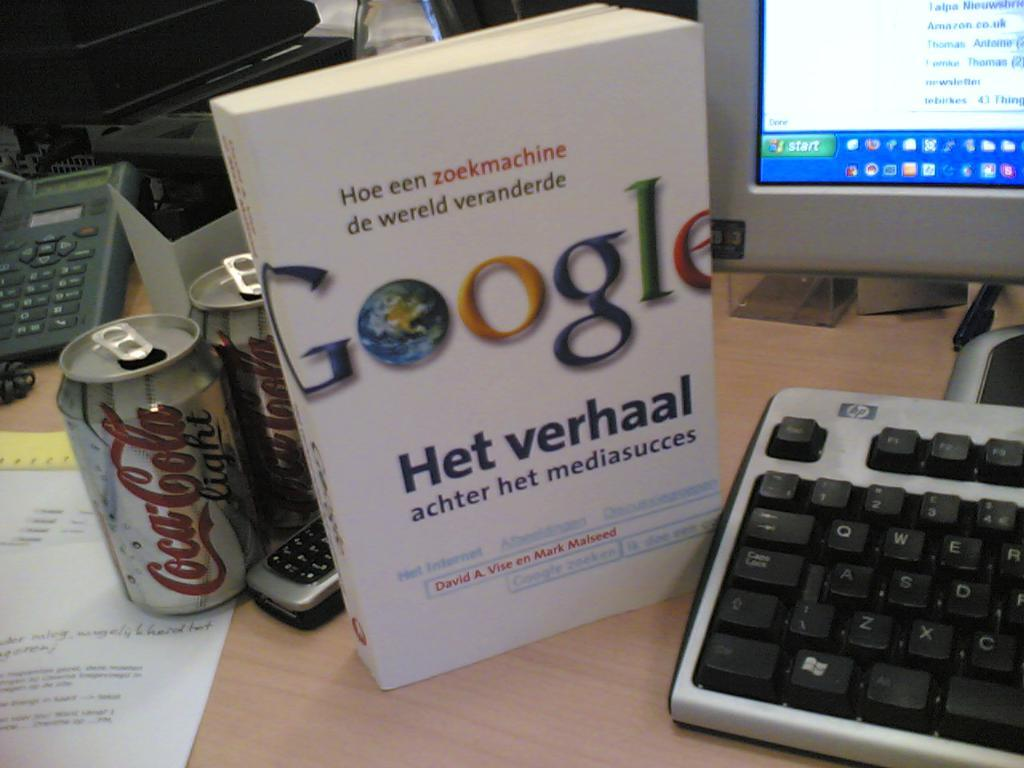<image>
Summarize the visual content of the image. A Coca Cola can and Google handbook beside a monitor and keyboard. 